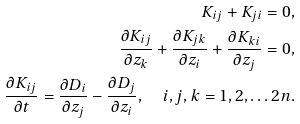Convert formula to latex. <formula><loc_0><loc_0><loc_500><loc_500>K _ { i j } + K _ { j i } = 0 , \\ \frac { \partial K _ { i j } } { \partial z _ { k } } + \frac { \partial K _ { j k } } { \partial z _ { i } } + \frac { \partial K _ { k i } } { \partial z _ { j } } = 0 , \\ \frac { \partial K _ { i j } } { \partial t } = \frac { \partial D _ { i } } { \partial z _ { j } } - \frac { \partial D _ { j } } { \partial z _ { i } } , \quad i , j , k = 1 , 2 , \dots 2 n .</formula> 